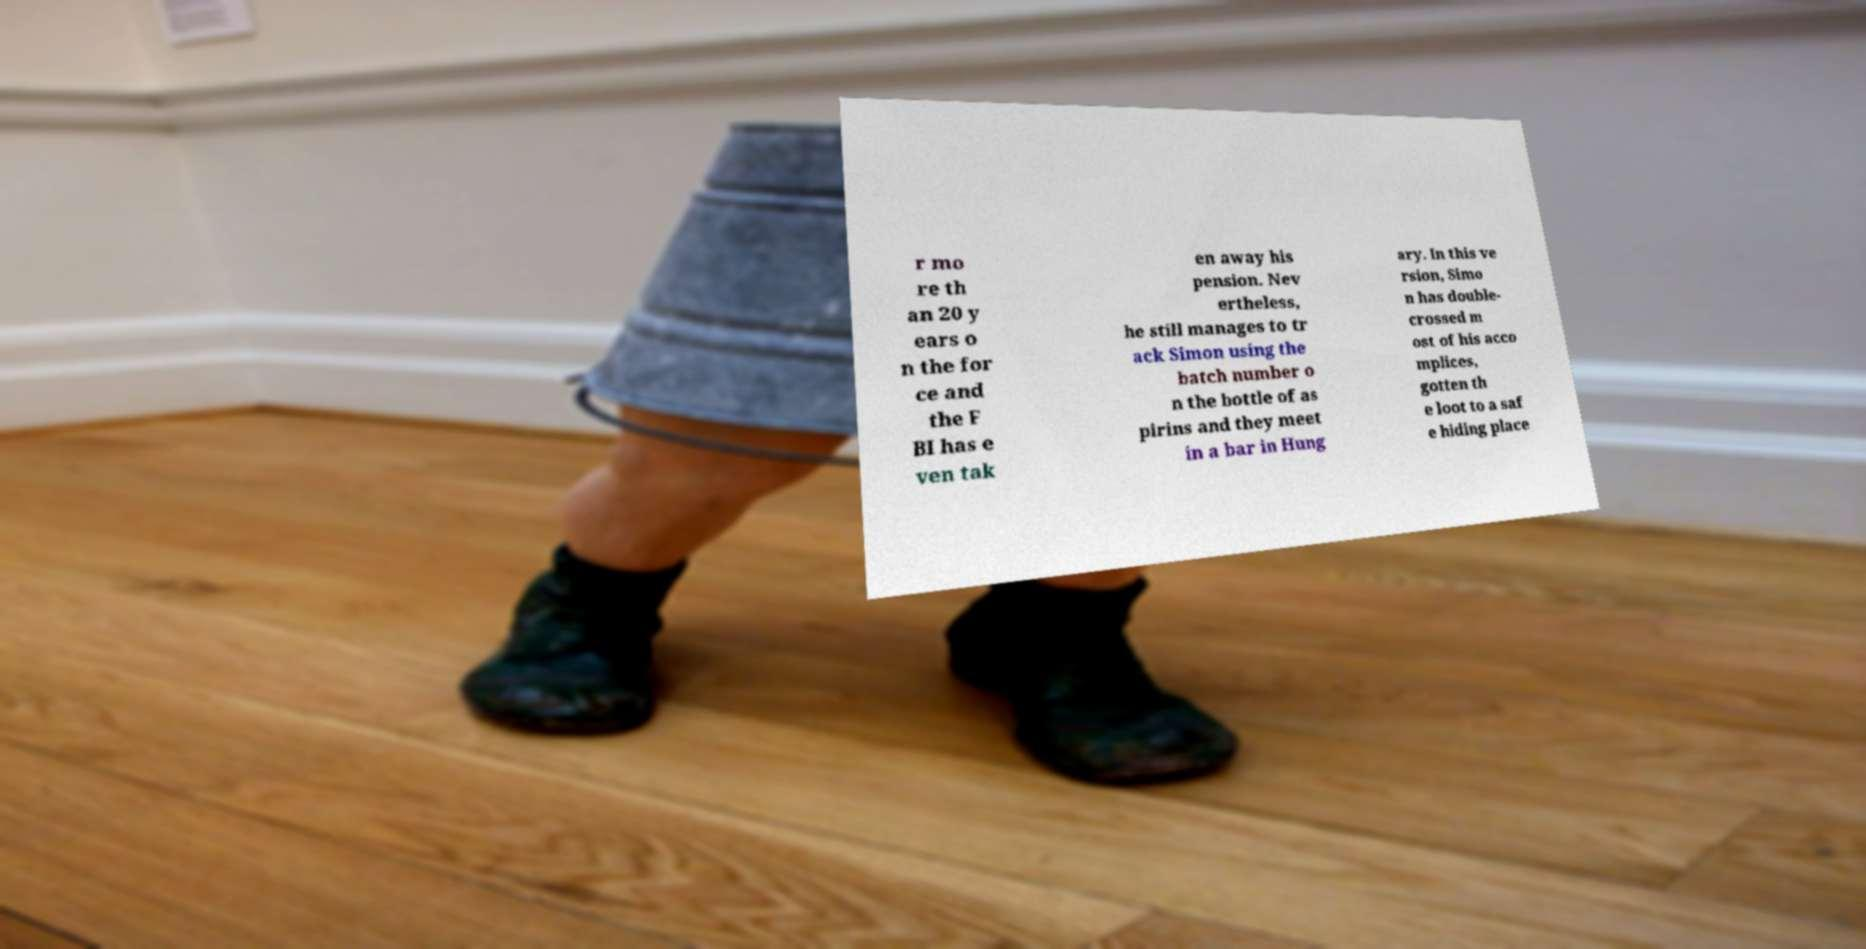There's text embedded in this image that I need extracted. Can you transcribe it verbatim? r mo re th an 20 y ears o n the for ce and the F BI has e ven tak en away his pension. Nev ertheless, he still manages to tr ack Simon using the batch number o n the bottle of as pirins and they meet in a bar in Hung ary. In this ve rsion, Simo n has double- crossed m ost of his acco mplices, gotten th e loot to a saf e hiding place 